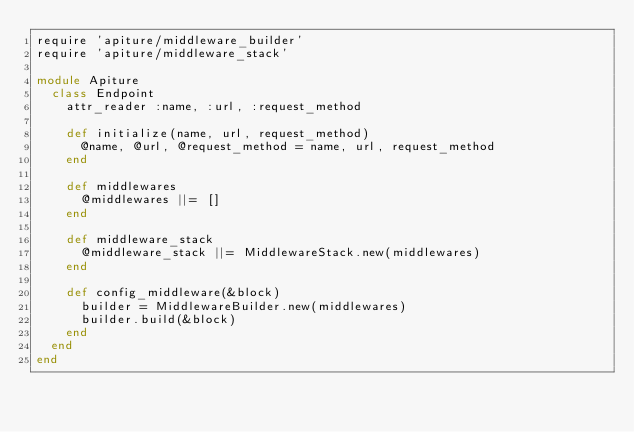<code> <loc_0><loc_0><loc_500><loc_500><_Ruby_>require 'apiture/middleware_builder'
require 'apiture/middleware_stack'

module Apiture
  class Endpoint
    attr_reader :name, :url, :request_method

    def initialize(name, url, request_method)
      @name, @url, @request_method = name, url, request_method
    end

    def middlewares
      @middlewares ||= []
    end

    def middleware_stack
      @middleware_stack ||= MiddlewareStack.new(middlewares)
    end

    def config_middleware(&block)
      builder = MiddlewareBuilder.new(middlewares)
      builder.build(&block)
    end
  end
end
</code> 